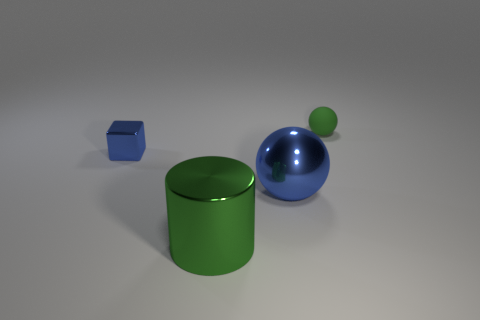What is the texture or material appearance of the objects? The objects appear to have a smooth, reflective surface, suggesting they may be made of a glossy material like plastic or polished metal. 